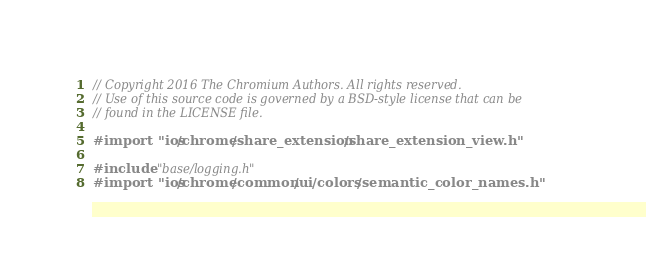Convert code to text. <code><loc_0><loc_0><loc_500><loc_500><_ObjectiveC_>// Copyright 2016 The Chromium Authors. All rights reserved.
// Use of this source code is governed by a BSD-style license that can be
// found in the LICENSE file.

#import "ios/chrome/share_extension/share_extension_view.h"

#include "base/logging.h"
#import "ios/chrome/common/ui/colors/semantic_color_names.h"</code> 